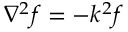Convert formula to latex. <formula><loc_0><loc_0><loc_500><loc_500>\nabla ^ { 2 } f = - k ^ { 2 } f</formula> 